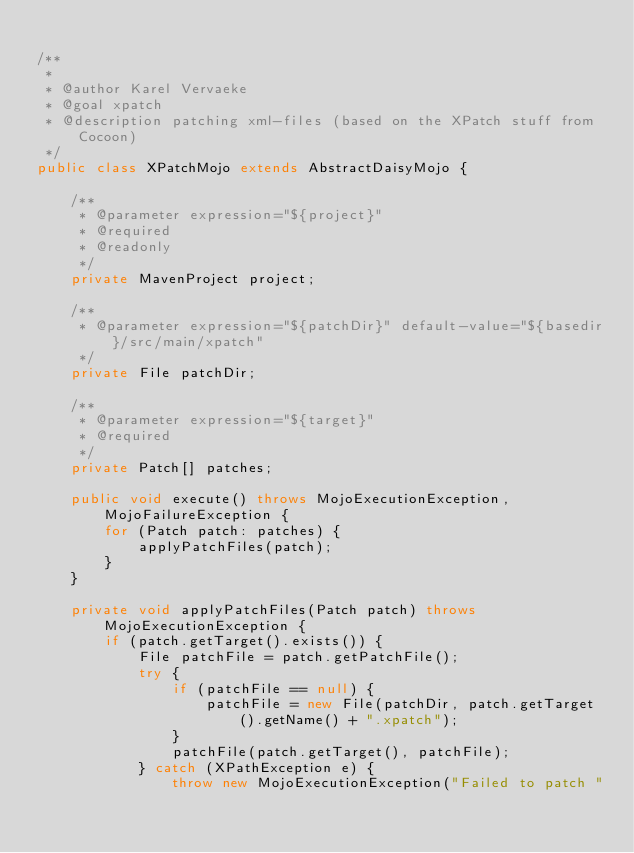Convert code to text. <code><loc_0><loc_0><loc_500><loc_500><_Java_>
/**
 *
 * @author Karel Vervaeke
 * @goal xpatch
 * @description patching xml-files (based on the XPatch stuff from Cocoon)
 */
public class XPatchMojo extends AbstractDaisyMojo {

    /**
     * @parameter expression="${project}"
     * @required
     * @readonly
     */
    private MavenProject project;

    /**
     * @parameter expression="${patchDir}" default-value="${basedir}/src/main/xpatch"
     */
    private File patchDir;
    
    /**
     * @parameter expression="${target}"
     * @required
     */
    private Patch[] patches;

    public void execute() throws MojoExecutionException, MojoFailureException {
        for (Patch patch: patches) {
            applyPatchFiles(patch);
        }
    }

    private void applyPatchFiles(Patch patch) throws MojoExecutionException {
        if (patch.getTarget().exists()) {
            File patchFile = patch.getPatchFile();
            try {
                if (patchFile == null) {
                    patchFile = new File(patchDir, patch.getTarget().getName() + ".xpatch");
                }
                patchFile(patch.getTarget(), patchFile);
            } catch (XPathException e) {
                throw new MojoExecutionException("Failed to patch "</code> 